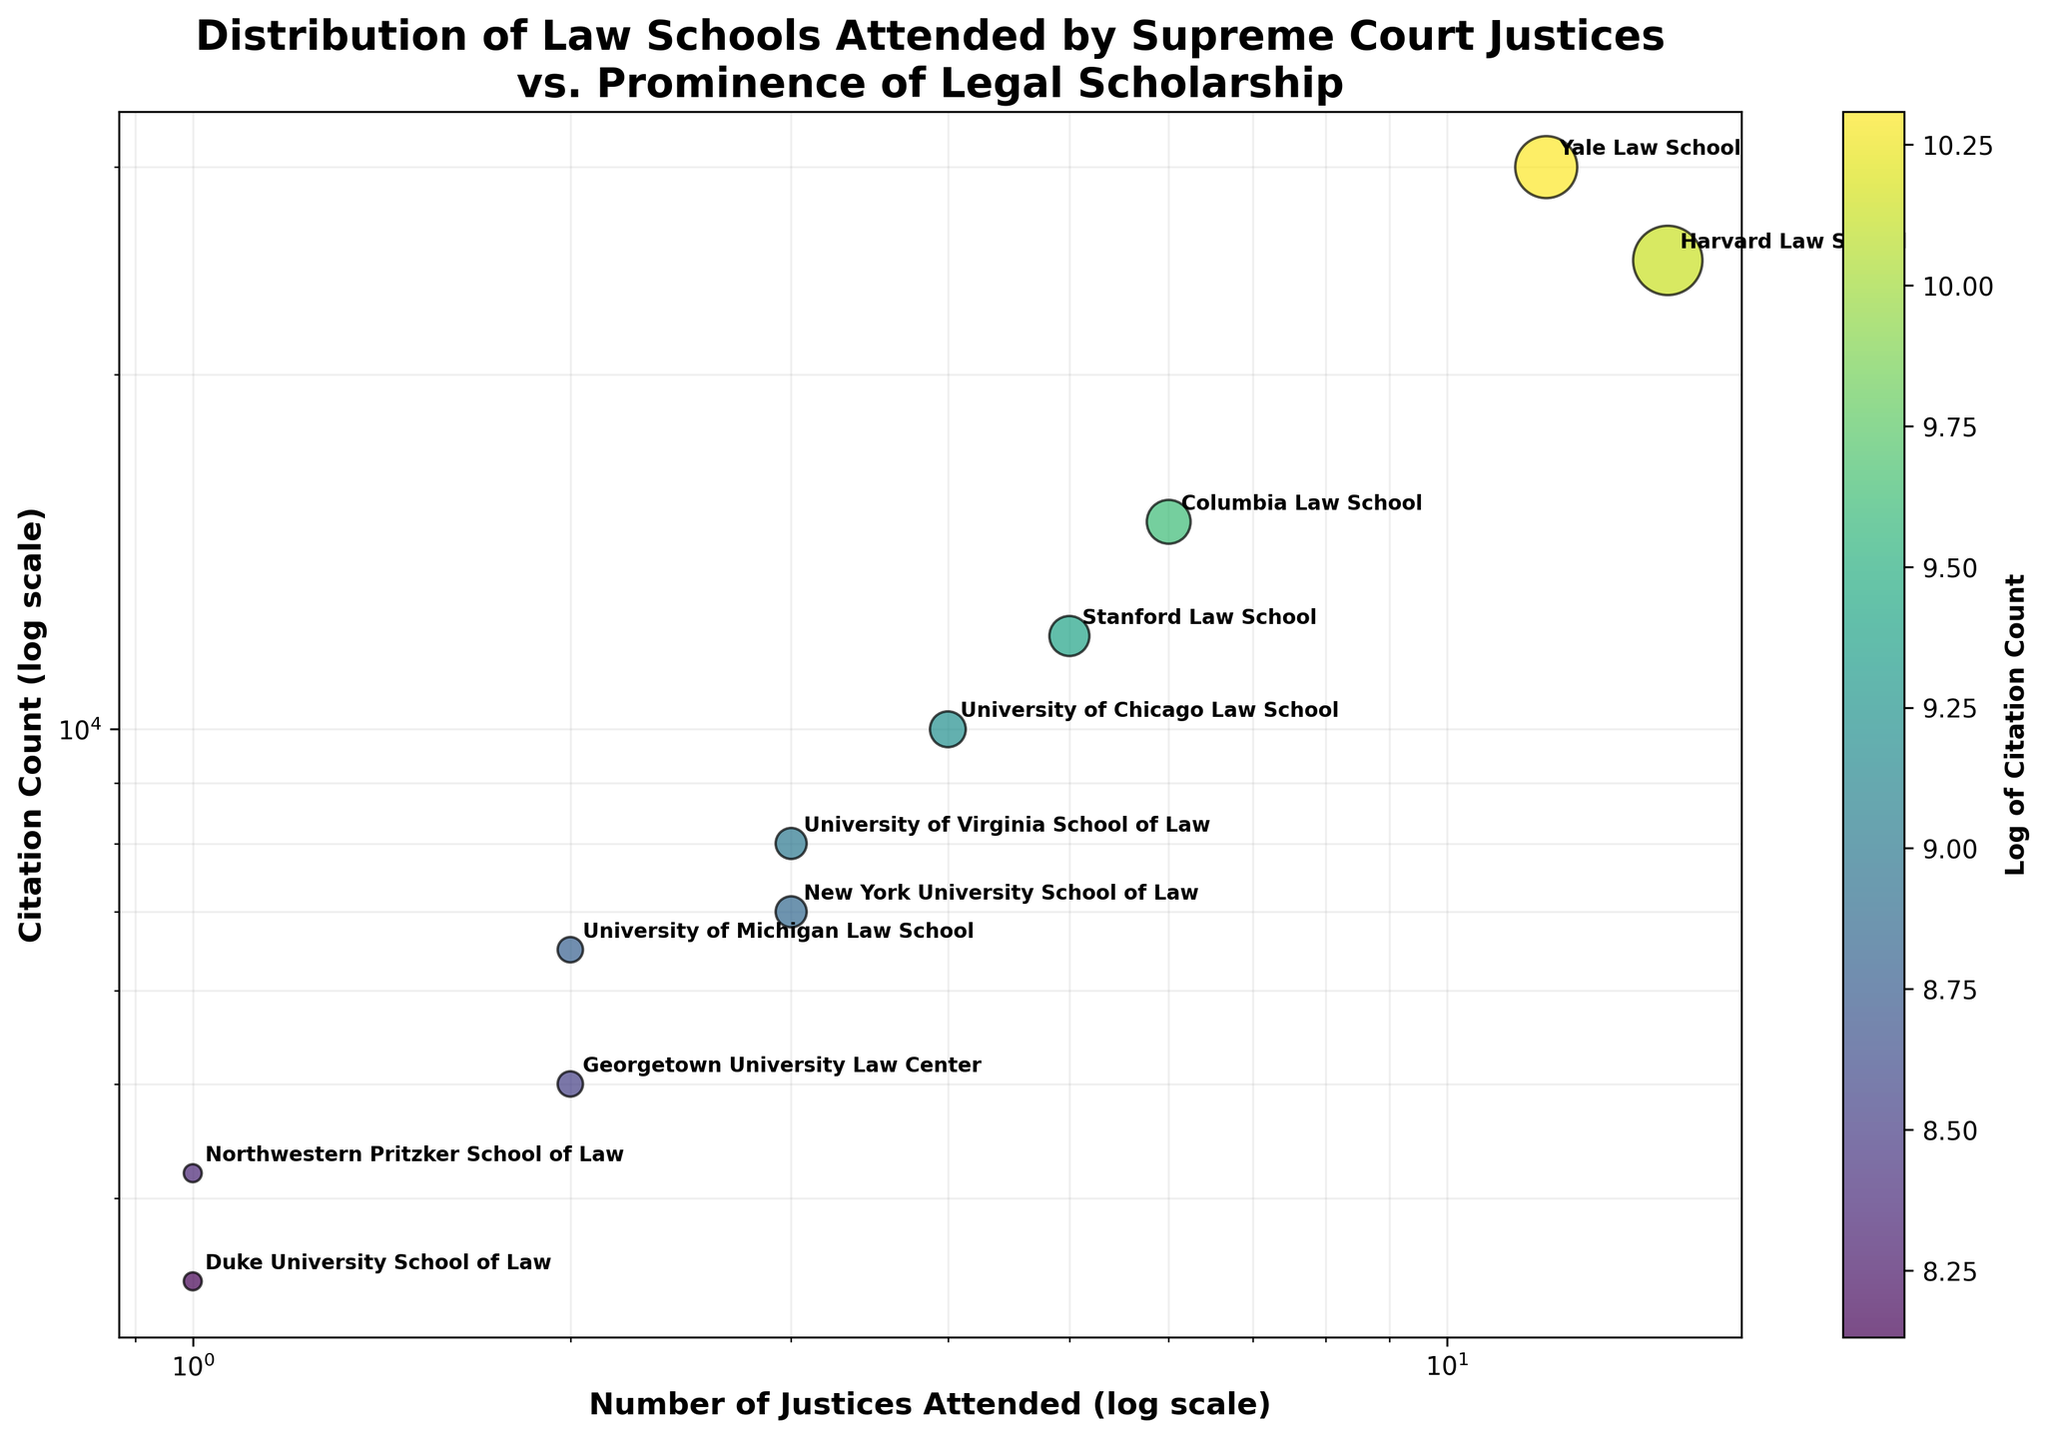What is the title of the scatter plot? The title of the scatter plot is located at the top of the figure and describes the main subject of the plot. It states the relationship between two elements associated with Supreme Court Justices and legal scholarship.
Answer: Distribution of Law Schools Attended by Supreme Court Justices vs. Prominence of Legal Scholarship How many law schools are represented in the plot? To find the number of law schools, count the distinct data points marked on the scatter plot, each representing a different law school.
Answer: 11 Which law school has the highest citation count? Look at the y-axis to find the data point with the highest vertical position. The label next to this point indicates the law school with the highest citation count.
Answer: Yale Law School What is the x-axis label of the scatter plot? The label for the x-axis is usually indicated at the bottom of the axis and describes what the horizontal measurements represent in the plot.
Answer: Number of Justices Attended (log scale) Which law school has the smallest number of justices attended? Identify the data point positioned furthest to the left on the x-axis. The label next to this point will indicate the law school with the smallest number of justices attended.
Answer: Northwestern Pritzker School of Law and Duke University School of Law Which law schools have the same number of justices attended? Review the x-axis to identify any data points that share the same horizontal position. The labels of these points will indicate which law schools have the same number of justices attended.
Answer: University of Virginia School of Law & New York University School of Law, University of Michigan Law School & Georgetown University Law Center What is the relationship between the number of justices attended and the citation count for Harvard Law School and Stanford Law School? Compare the positions of the data points for Harvard Law School and Stanford Law School. Note the x-axis and y-axis values to determine how the number of justices and citation counts relate between the two.
Answer: Harvard Law School has more justices attended and a higher citation count than Stanford Law School Which law schools have a citation count of at least 10,000? Look at the y-axis for data points that are at or above the 10,000 mark. Identify the corresponding law school labels for these points.
Answer: Harvard Law School, Yale Law School, Columbia Law School, Stanford Law School, University of Chicago Law School What is the relationship between Georgetown University Law Center and University of Michigan Law School in terms of citation count? Compare the y-axis positions of the data points for these two law schools. Determine which one is higher to see which has more citations.
Answer: University of Michigan Law School has more citations than Georgetown University Law Center Which law school has a citation count closest to 7,000? Identify the data point nearest to the 7,000 mark on the y-axis. The label next to this point indicates the law school with a citation count closest to 7,000.
Answer: New York University School of Law 